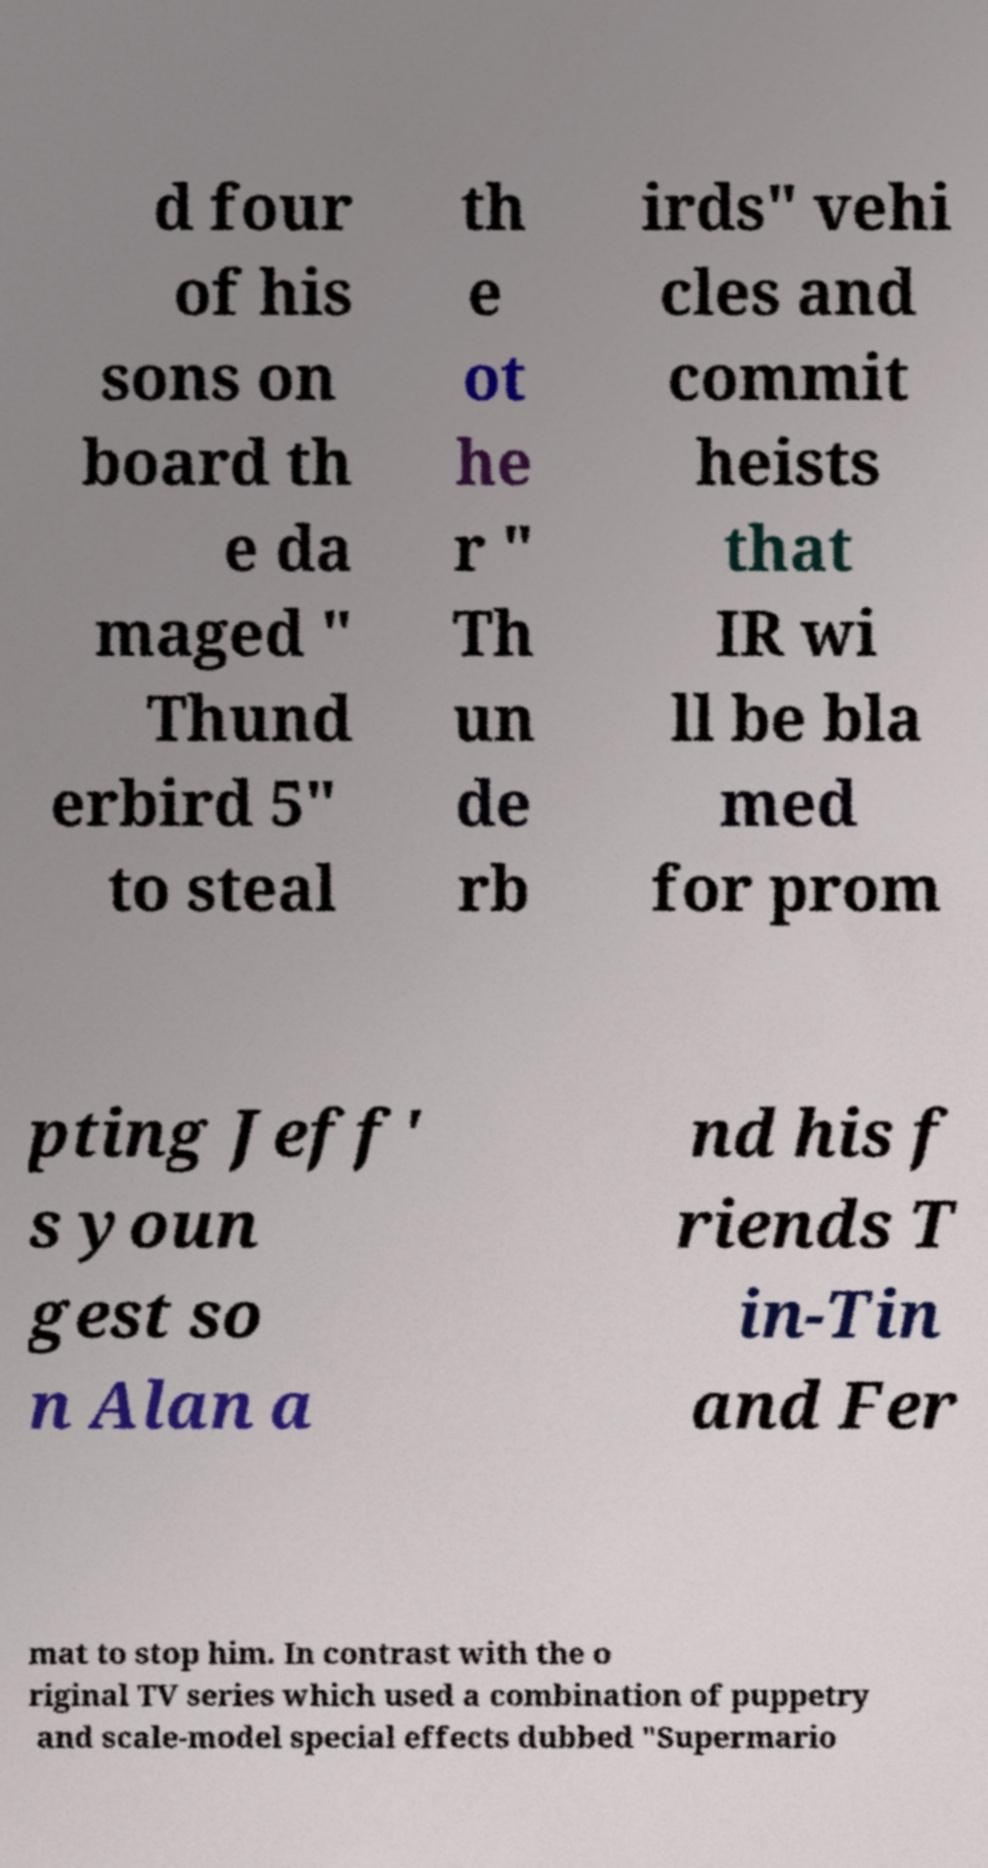Can you accurately transcribe the text from the provided image for me? d four of his sons on board th e da maged " Thund erbird 5" to steal th e ot he r " Th un de rb irds" vehi cles and commit heists that IR wi ll be bla med for prom pting Jeff' s youn gest so n Alan a nd his f riends T in-Tin and Fer mat to stop him. In contrast with the o riginal TV series which used a combination of puppetry and scale-model special effects dubbed "Supermario 